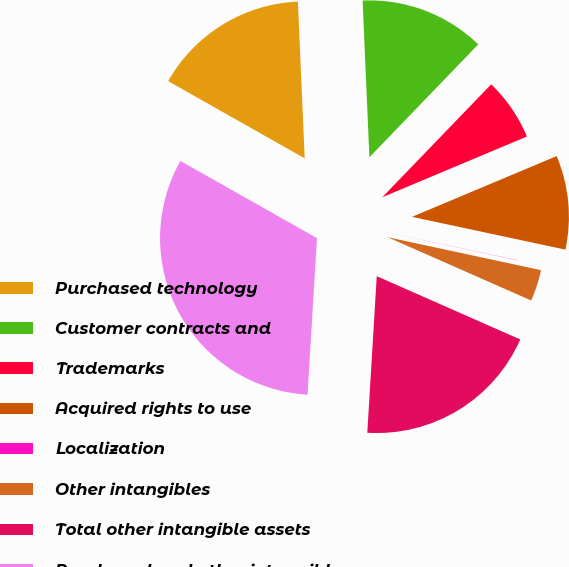Convert chart. <chart><loc_0><loc_0><loc_500><loc_500><pie_chart><fcel>Purchased technology<fcel>Customer contracts and<fcel>Trademarks<fcel>Acquired rights to use<fcel>Localization<fcel>Other intangibles<fcel>Total other intangible assets<fcel>Purchased and other intangible<nl><fcel>16.12%<fcel>12.9%<fcel>6.46%<fcel>9.68%<fcel>0.02%<fcel>3.24%<fcel>19.35%<fcel>32.23%<nl></chart> 